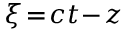Convert formula to latex. <formula><loc_0><loc_0><loc_500><loc_500>\xi \, = \, c t \, - \, z</formula> 